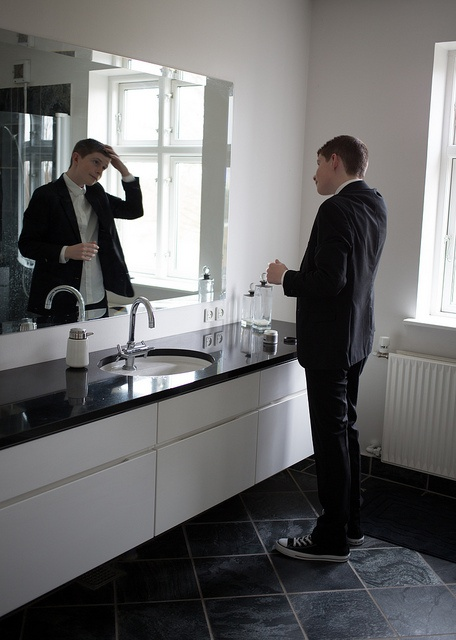Describe the objects in this image and their specific colors. I can see people in gray, black, and darkgray tones, sink in gray, darkgray, and black tones, and bottle in gray, darkgray, and lightgray tones in this image. 